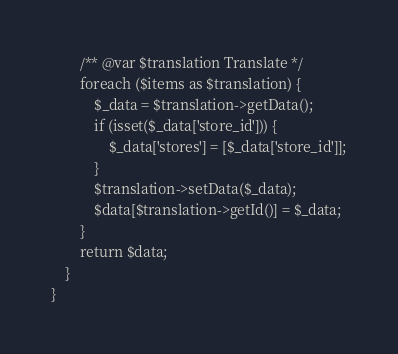Convert code to text. <code><loc_0><loc_0><loc_500><loc_500><_PHP_>        /** @var $translation Translate */
        foreach ($items as $translation) {
            $_data = $translation->getData();
            if (isset($_data['store_id'])) {
                $_data['stores'] = [$_data['store_id']];
            }
            $translation->setData($_data);
            $data[$translation->getId()] = $_data;
        }
        return $data;
    }
}
</code> 